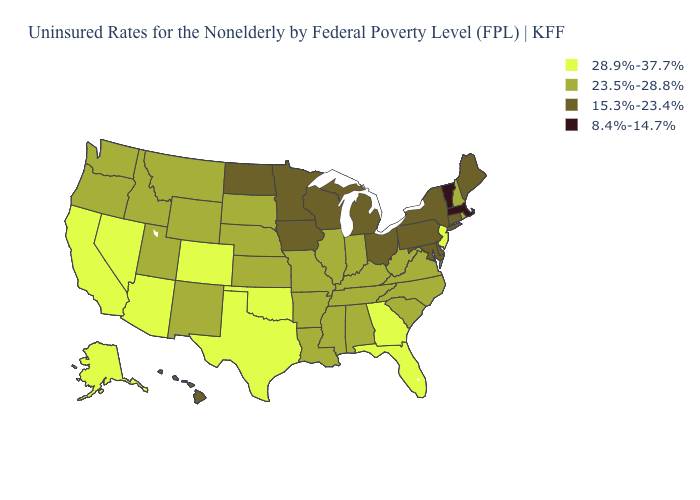What is the value of California?
Give a very brief answer. 28.9%-37.7%. Does New York have the same value as Oregon?
Be succinct. No. What is the lowest value in the USA?
Write a very short answer. 8.4%-14.7%. Name the states that have a value in the range 28.9%-37.7%?
Give a very brief answer. Alaska, Arizona, California, Colorado, Florida, Georgia, Nevada, New Jersey, Oklahoma, Texas. Among the states that border Indiana , which have the lowest value?
Short answer required. Michigan, Ohio. What is the value of Hawaii?
Concise answer only. 15.3%-23.4%. Name the states that have a value in the range 28.9%-37.7%?
Concise answer only. Alaska, Arizona, California, Colorado, Florida, Georgia, Nevada, New Jersey, Oklahoma, Texas. Does Michigan have the highest value in the MidWest?
Keep it brief. No. Name the states that have a value in the range 15.3%-23.4%?
Give a very brief answer. Connecticut, Delaware, Hawaii, Iowa, Maine, Maryland, Michigan, Minnesota, New York, North Dakota, Ohio, Pennsylvania, Wisconsin. What is the lowest value in states that border Mississippi?
Write a very short answer. 23.5%-28.8%. Does Massachusetts have the lowest value in the USA?
Be succinct. Yes. Name the states that have a value in the range 8.4%-14.7%?
Answer briefly. Massachusetts, Vermont. What is the value of West Virginia?
Quick response, please. 23.5%-28.8%. Name the states that have a value in the range 23.5%-28.8%?
Write a very short answer. Alabama, Arkansas, Idaho, Illinois, Indiana, Kansas, Kentucky, Louisiana, Mississippi, Missouri, Montana, Nebraska, New Hampshire, New Mexico, North Carolina, Oregon, Rhode Island, South Carolina, South Dakota, Tennessee, Utah, Virginia, Washington, West Virginia, Wyoming. 